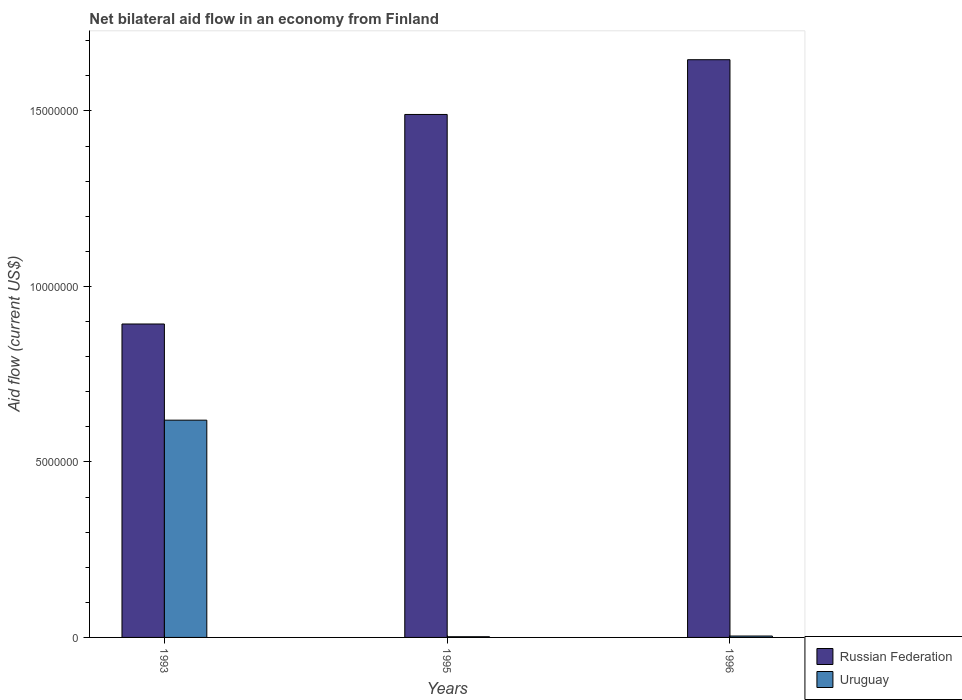How many different coloured bars are there?
Offer a very short reply. 2. Are the number of bars per tick equal to the number of legend labels?
Give a very brief answer. Yes. How many bars are there on the 2nd tick from the right?
Your answer should be very brief. 2. What is the label of the 2nd group of bars from the left?
Offer a very short reply. 1995. In how many cases, is the number of bars for a given year not equal to the number of legend labels?
Your answer should be very brief. 0. Across all years, what is the maximum net bilateral aid flow in Uruguay?
Your answer should be compact. 6.19e+06. Across all years, what is the minimum net bilateral aid flow in Uruguay?
Your answer should be very brief. 2.00e+04. What is the total net bilateral aid flow in Russian Federation in the graph?
Provide a succinct answer. 4.03e+07. What is the difference between the net bilateral aid flow in Uruguay in 1995 and that in 1996?
Give a very brief answer. -2.00e+04. What is the difference between the net bilateral aid flow in Uruguay in 1993 and the net bilateral aid flow in Russian Federation in 1995?
Offer a very short reply. -8.71e+06. What is the average net bilateral aid flow in Russian Federation per year?
Your answer should be very brief. 1.34e+07. In the year 1996, what is the difference between the net bilateral aid flow in Uruguay and net bilateral aid flow in Russian Federation?
Offer a very short reply. -1.64e+07. In how many years, is the net bilateral aid flow in Uruguay greater than 6000000 US$?
Offer a very short reply. 1. What is the ratio of the net bilateral aid flow in Russian Federation in 1993 to that in 1996?
Give a very brief answer. 0.54. Is the net bilateral aid flow in Russian Federation in 1993 less than that in 1995?
Offer a terse response. Yes. Is the difference between the net bilateral aid flow in Uruguay in 1993 and 1995 greater than the difference between the net bilateral aid flow in Russian Federation in 1993 and 1995?
Your answer should be very brief. Yes. What is the difference between the highest and the second highest net bilateral aid flow in Uruguay?
Keep it short and to the point. 6.15e+06. What is the difference between the highest and the lowest net bilateral aid flow in Uruguay?
Make the answer very short. 6.17e+06. Is the sum of the net bilateral aid flow in Russian Federation in 1993 and 1996 greater than the maximum net bilateral aid flow in Uruguay across all years?
Offer a very short reply. Yes. What does the 1st bar from the left in 1995 represents?
Provide a short and direct response. Russian Federation. What does the 2nd bar from the right in 1995 represents?
Make the answer very short. Russian Federation. How many bars are there?
Your answer should be compact. 6. Are all the bars in the graph horizontal?
Offer a terse response. No. How many years are there in the graph?
Your response must be concise. 3. What is the difference between two consecutive major ticks on the Y-axis?
Provide a short and direct response. 5.00e+06. Does the graph contain grids?
Ensure brevity in your answer.  No. How are the legend labels stacked?
Your response must be concise. Vertical. What is the title of the graph?
Your answer should be very brief. Net bilateral aid flow in an economy from Finland. Does "Trinidad and Tobago" appear as one of the legend labels in the graph?
Provide a short and direct response. No. What is the label or title of the X-axis?
Ensure brevity in your answer.  Years. What is the label or title of the Y-axis?
Your response must be concise. Aid flow (current US$). What is the Aid flow (current US$) of Russian Federation in 1993?
Offer a terse response. 8.93e+06. What is the Aid flow (current US$) of Uruguay in 1993?
Offer a very short reply. 6.19e+06. What is the Aid flow (current US$) of Russian Federation in 1995?
Keep it short and to the point. 1.49e+07. What is the Aid flow (current US$) in Russian Federation in 1996?
Give a very brief answer. 1.65e+07. What is the Aid flow (current US$) in Uruguay in 1996?
Ensure brevity in your answer.  4.00e+04. Across all years, what is the maximum Aid flow (current US$) of Russian Federation?
Provide a short and direct response. 1.65e+07. Across all years, what is the maximum Aid flow (current US$) of Uruguay?
Provide a short and direct response. 6.19e+06. Across all years, what is the minimum Aid flow (current US$) in Russian Federation?
Your answer should be compact. 8.93e+06. What is the total Aid flow (current US$) of Russian Federation in the graph?
Your answer should be compact. 4.03e+07. What is the total Aid flow (current US$) in Uruguay in the graph?
Make the answer very short. 6.25e+06. What is the difference between the Aid flow (current US$) of Russian Federation in 1993 and that in 1995?
Make the answer very short. -5.97e+06. What is the difference between the Aid flow (current US$) in Uruguay in 1993 and that in 1995?
Provide a succinct answer. 6.17e+06. What is the difference between the Aid flow (current US$) in Russian Federation in 1993 and that in 1996?
Make the answer very short. -7.53e+06. What is the difference between the Aid flow (current US$) in Uruguay in 1993 and that in 1996?
Your response must be concise. 6.15e+06. What is the difference between the Aid flow (current US$) of Russian Federation in 1995 and that in 1996?
Make the answer very short. -1.56e+06. What is the difference between the Aid flow (current US$) in Uruguay in 1995 and that in 1996?
Offer a terse response. -2.00e+04. What is the difference between the Aid flow (current US$) of Russian Federation in 1993 and the Aid flow (current US$) of Uruguay in 1995?
Keep it short and to the point. 8.91e+06. What is the difference between the Aid flow (current US$) in Russian Federation in 1993 and the Aid flow (current US$) in Uruguay in 1996?
Keep it short and to the point. 8.89e+06. What is the difference between the Aid flow (current US$) in Russian Federation in 1995 and the Aid flow (current US$) in Uruguay in 1996?
Give a very brief answer. 1.49e+07. What is the average Aid flow (current US$) of Russian Federation per year?
Offer a terse response. 1.34e+07. What is the average Aid flow (current US$) in Uruguay per year?
Your answer should be compact. 2.08e+06. In the year 1993, what is the difference between the Aid flow (current US$) of Russian Federation and Aid flow (current US$) of Uruguay?
Give a very brief answer. 2.74e+06. In the year 1995, what is the difference between the Aid flow (current US$) of Russian Federation and Aid flow (current US$) of Uruguay?
Your answer should be compact. 1.49e+07. In the year 1996, what is the difference between the Aid flow (current US$) of Russian Federation and Aid flow (current US$) of Uruguay?
Provide a succinct answer. 1.64e+07. What is the ratio of the Aid flow (current US$) of Russian Federation in 1993 to that in 1995?
Provide a succinct answer. 0.6. What is the ratio of the Aid flow (current US$) of Uruguay in 1993 to that in 1995?
Your response must be concise. 309.5. What is the ratio of the Aid flow (current US$) in Russian Federation in 1993 to that in 1996?
Give a very brief answer. 0.54. What is the ratio of the Aid flow (current US$) of Uruguay in 1993 to that in 1996?
Offer a terse response. 154.75. What is the ratio of the Aid flow (current US$) in Russian Federation in 1995 to that in 1996?
Make the answer very short. 0.91. What is the ratio of the Aid flow (current US$) of Uruguay in 1995 to that in 1996?
Give a very brief answer. 0.5. What is the difference between the highest and the second highest Aid flow (current US$) of Russian Federation?
Keep it short and to the point. 1.56e+06. What is the difference between the highest and the second highest Aid flow (current US$) in Uruguay?
Your answer should be compact. 6.15e+06. What is the difference between the highest and the lowest Aid flow (current US$) in Russian Federation?
Your response must be concise. 7.53e+06. What is the difference between the highest and the lowest Aid flow (current US$) of Uruguay?
Keep it short and to the point. 6.17e+06. 